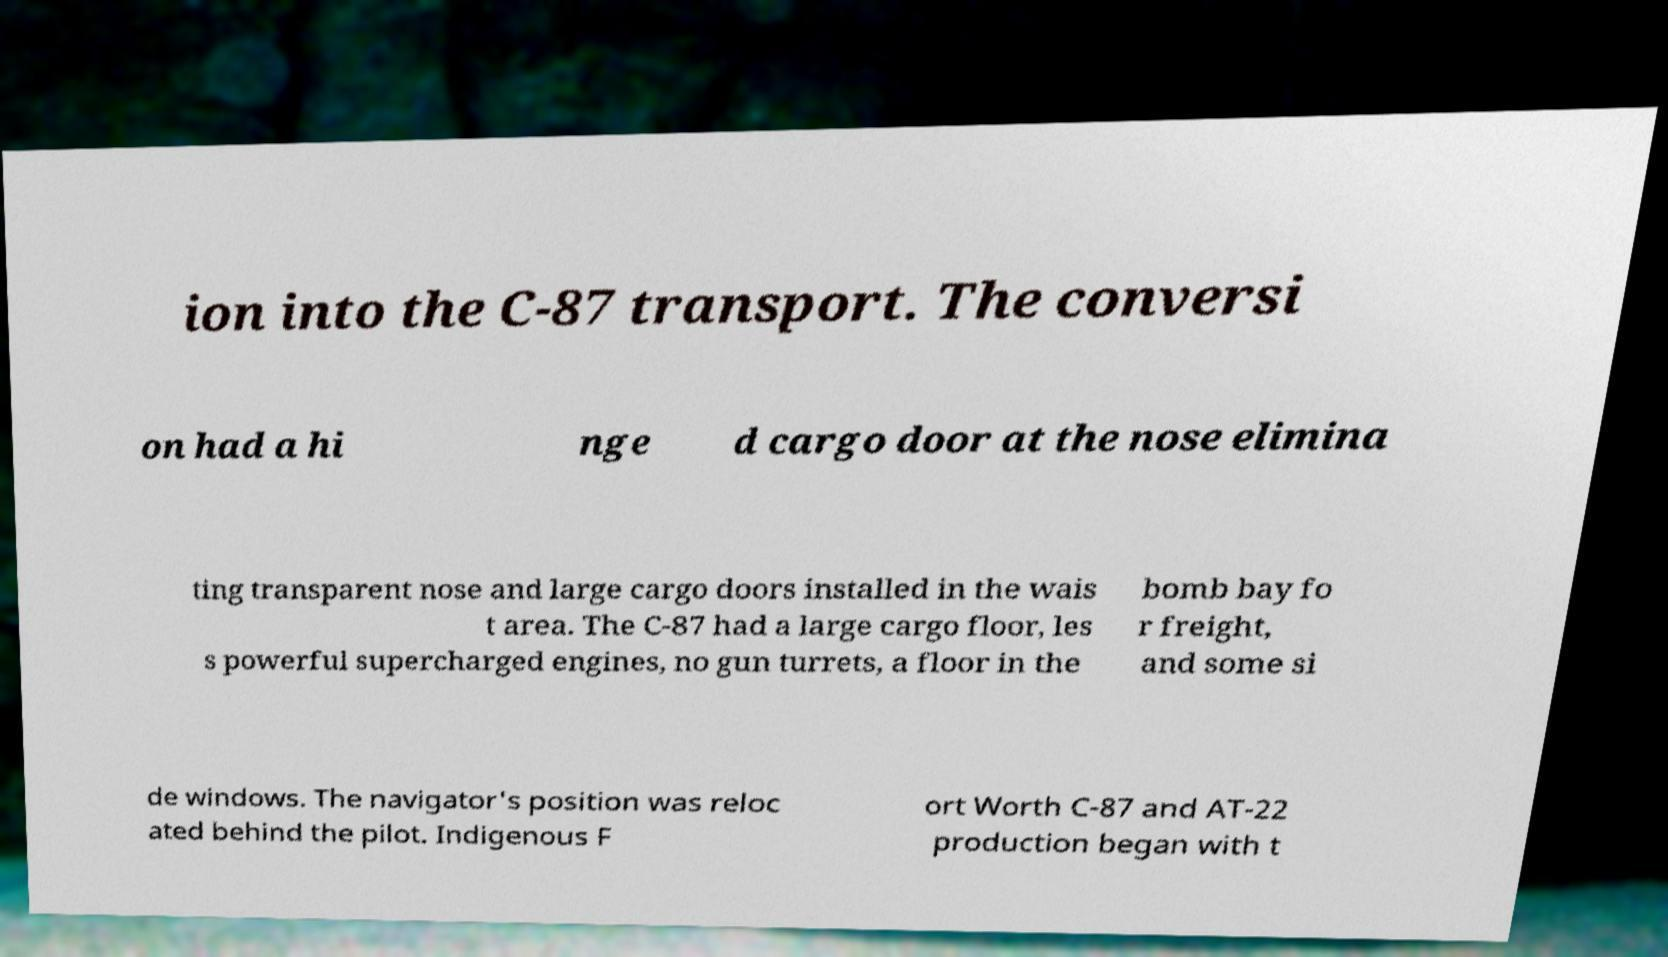For documentation purposes, I need the text within this image transcribed. Could you provide that? ion into the C-87 transport. The conversi on had a hi nge d cargo door at the nose elimina ting transparent nose and large cargo doors installed in the wais t area. The C-87 had a large cargo floor, les s powerful supercharged engines, no gun turrets, a floor in the bomb bay fo r freight, and some si de windows. The navigator's position was reloc ated behind the pilot. Indigenous F ort Worth C-87 and AT-22 production began with t 